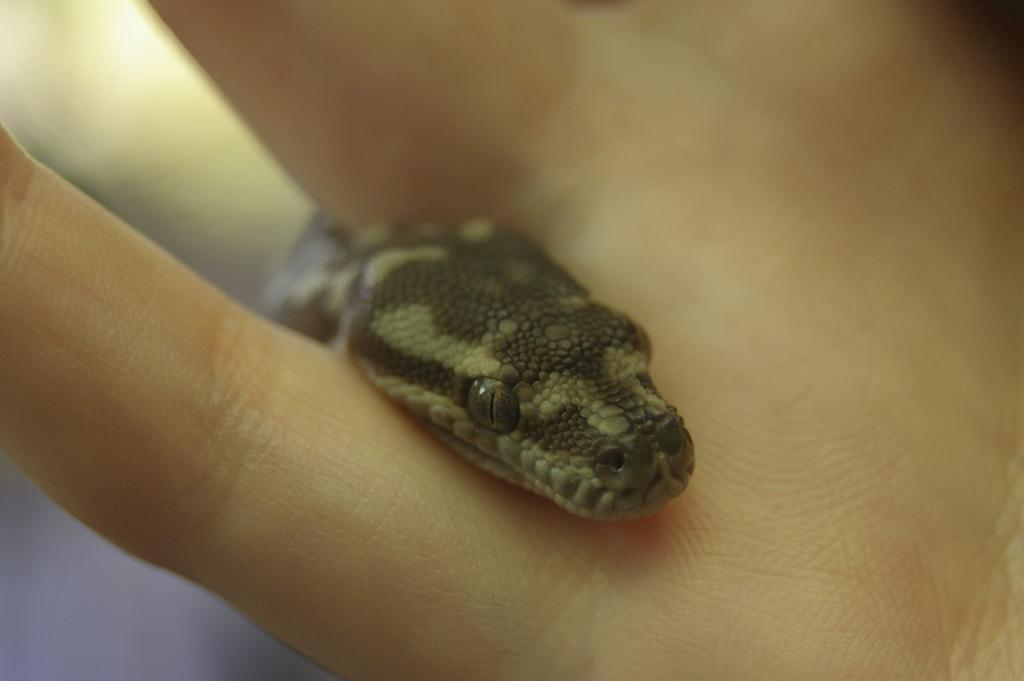What is the main subject of the image? There is a person in the image. What is the person holding in the image? The person is holding a snake. Can you describe the background of the image? The background of the image is blurry. What type of apparel is the boy wearing in the image? There is no boy present in the image, and no apparel is mentioned in the provided facts. 